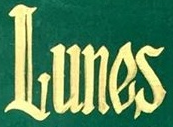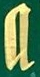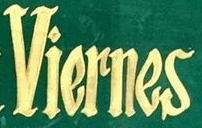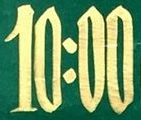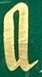What words are shown in these images in order, separated by a semicolon? Lunes; a; Viernes; 10:00; a 